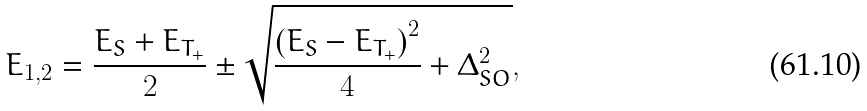Convert formula to latex. <formula><loc_0><loc_0><loc_500><loc_500>E _ { 1 , 2 } = \frac { E _ { S } + E _ { T _ { + } } } { 2 } \pm \sqrt { \frac { \left ( E _ { S } - E _ { T _ { + } } \right ) ^ { 2 } } { 4 } + \Delta _ { S O } ^ { 2 } } ,</formula> 